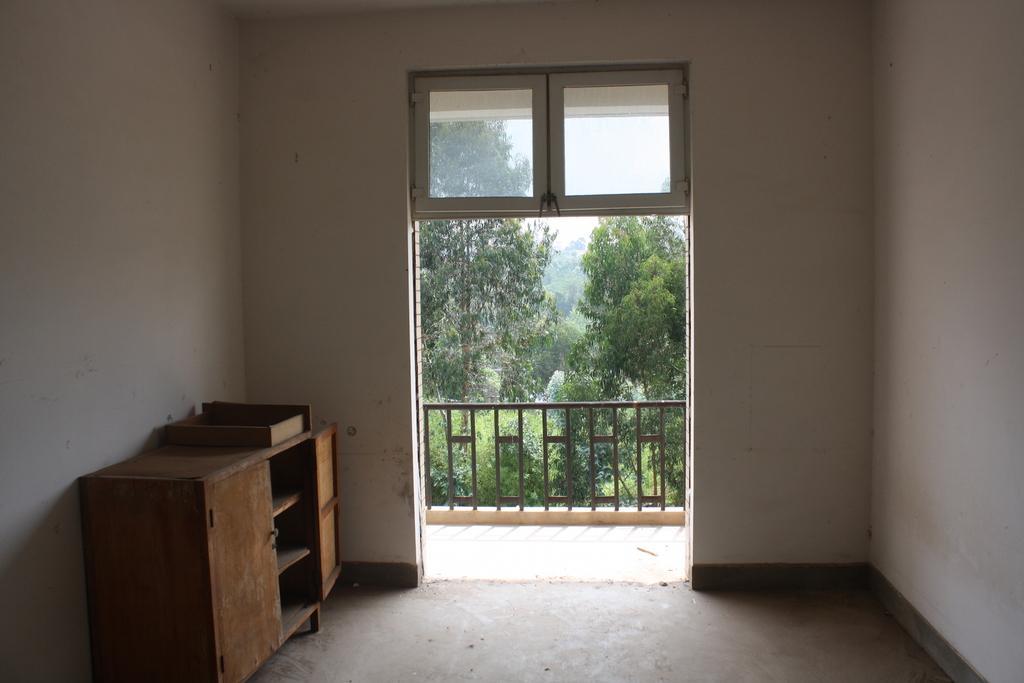Could you give a brief overview of what you see in this image? This is a place where we have a wooden desk on the left side and a window and a door and some plants outside. 